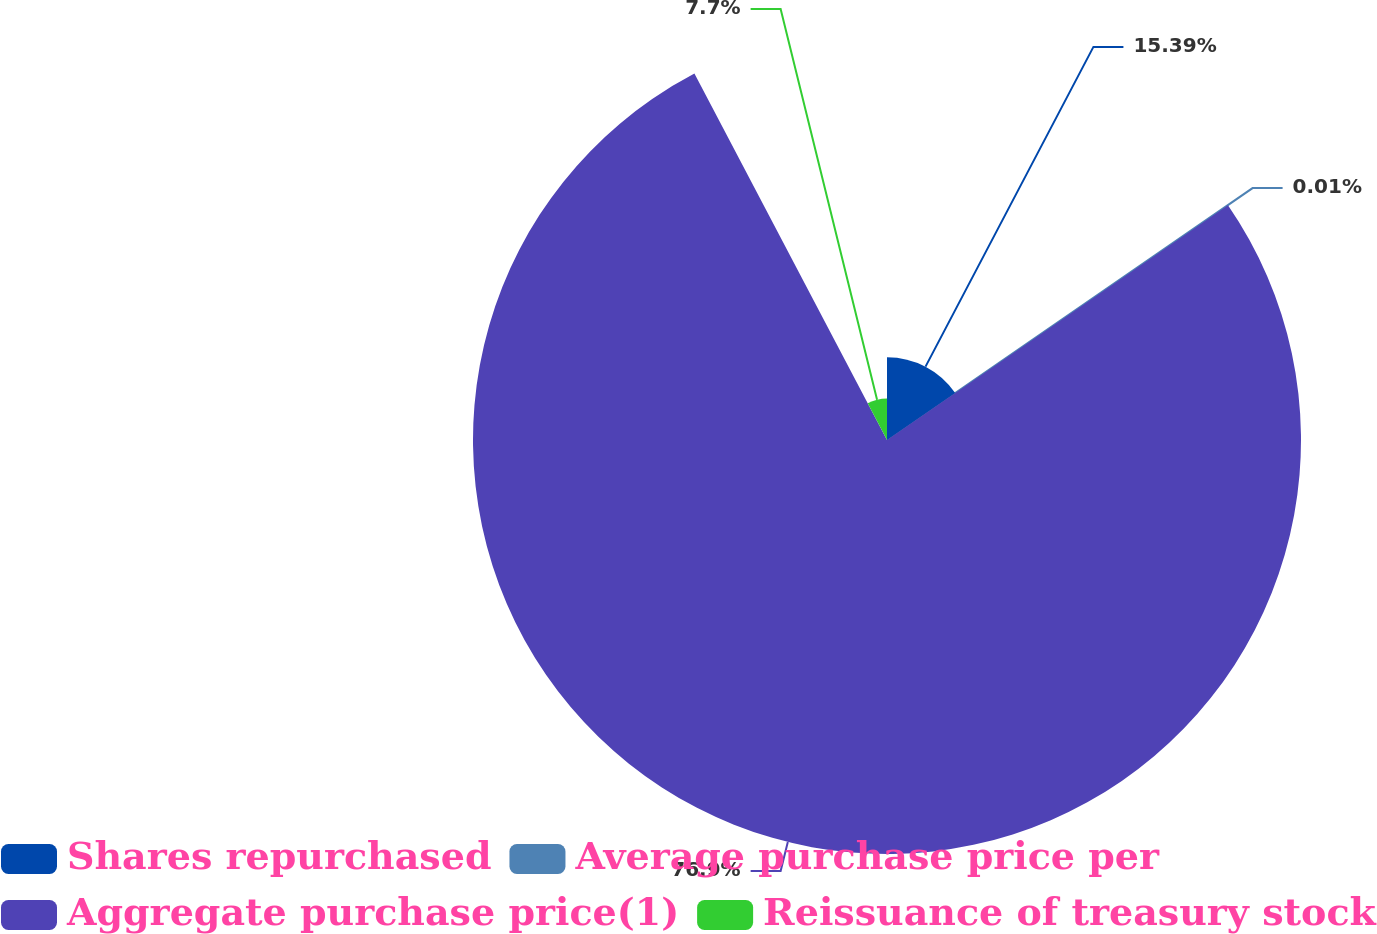Convert chart. <chart><loc_0><loc_0><loc_500><loc_500><pie_chart><fcel>Shares repurchased<fcel>Average purchase price per<fcel>Aggregate purchase price(1)<fcel>Reissuance of treasury stock<nl><fcel>15.39%<fcel>0.01%<fcel>76.89%<fcel>7.7%<nl></chart> 